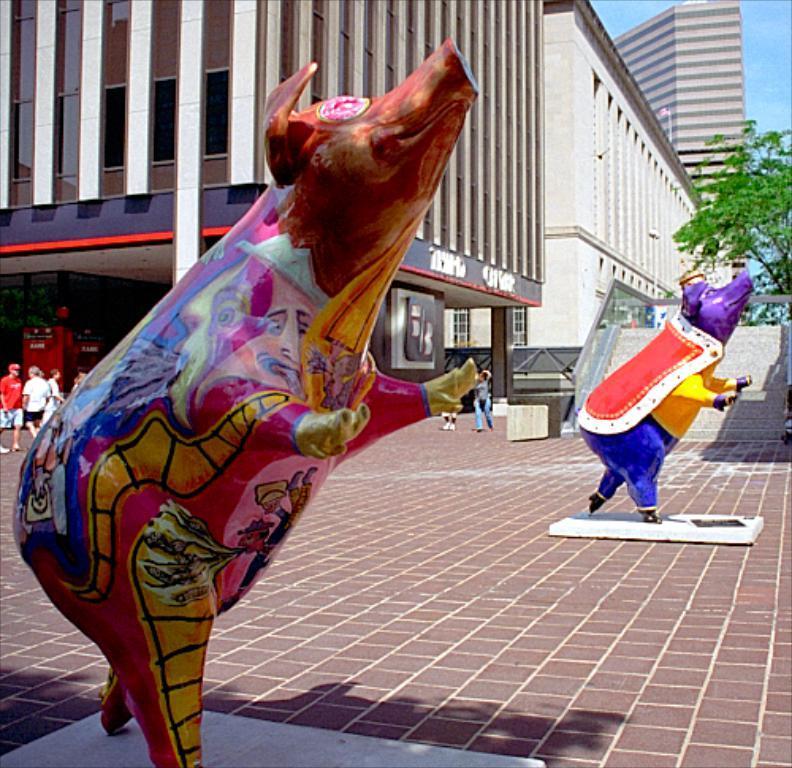Can you describe this image briefly? In this picture I can see there are statues of animal, there are few people walking on the left side and there are a few buildings and there is a tree at the right side. The sky is clear. 